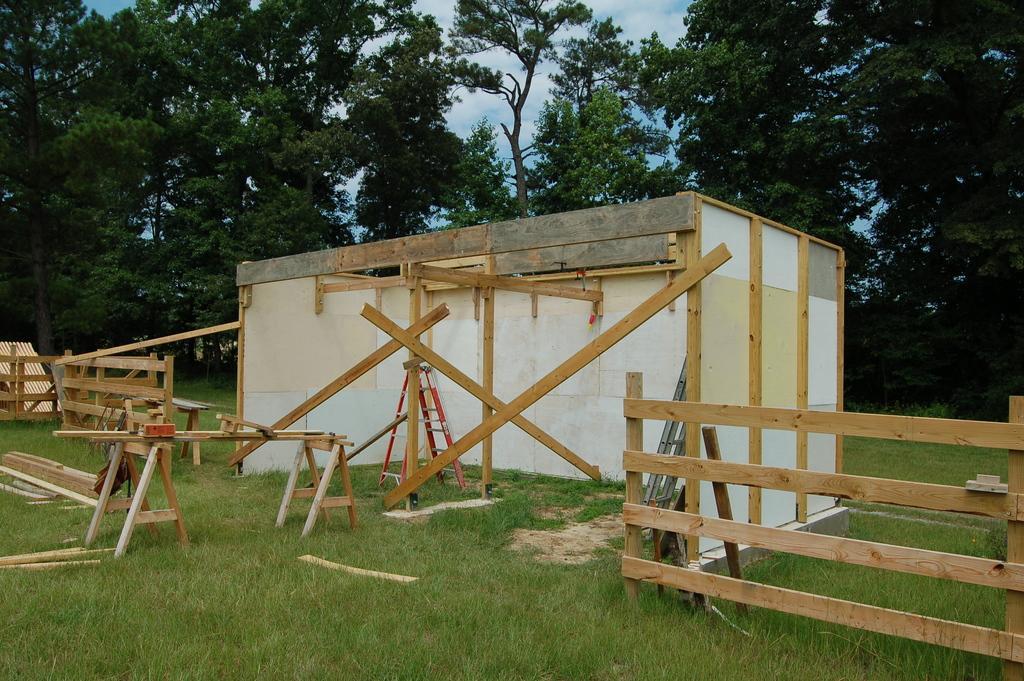In one or two sentences, can you explain what this image depicts? In the image there is a wooden room with wooden fence on either side of it on the grassland and behind it there are trees all over the place. 